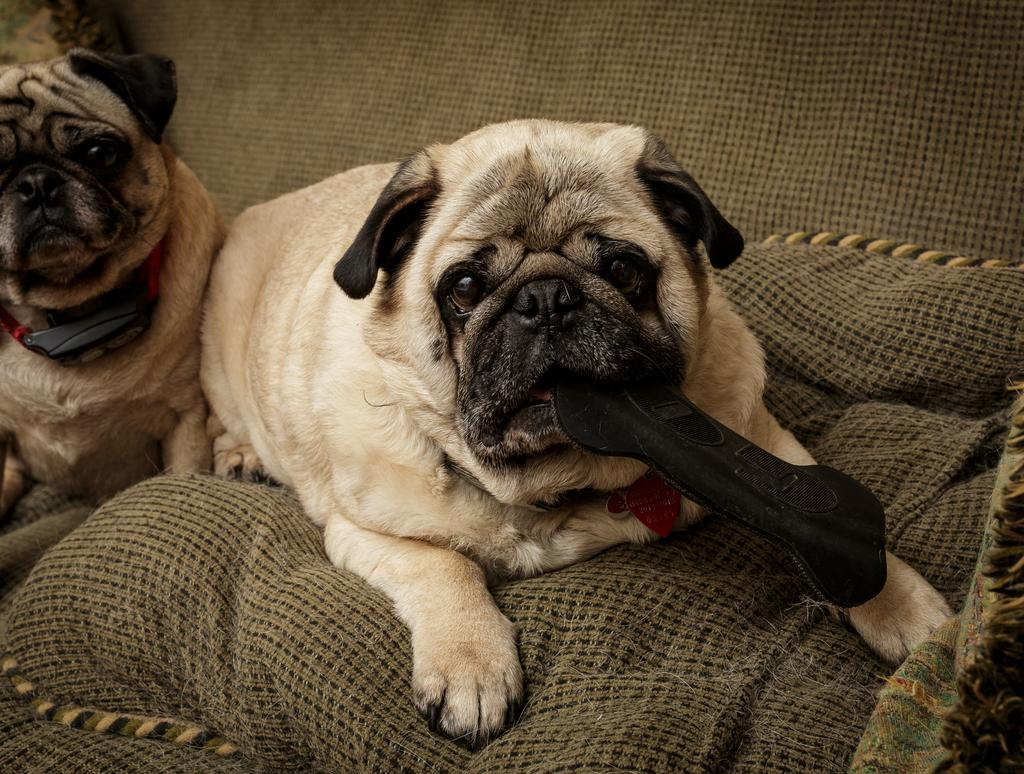What type of animal can be seen on the left side of the sofa in the image? There is a dog on a sofa on the left side of the image. Can you describe the position of the second dog in the image? There is another dog on a pillow on the sofa in the middle of the image. What is the overall color of the background in the image? The background color of the image is gray. What type of yarn is the dog on the left side of the sofa using to knit a stocking in the image? There is no yarn or knitting activity present in the image; the dogs are simply sitting on the sofa and pillow. 